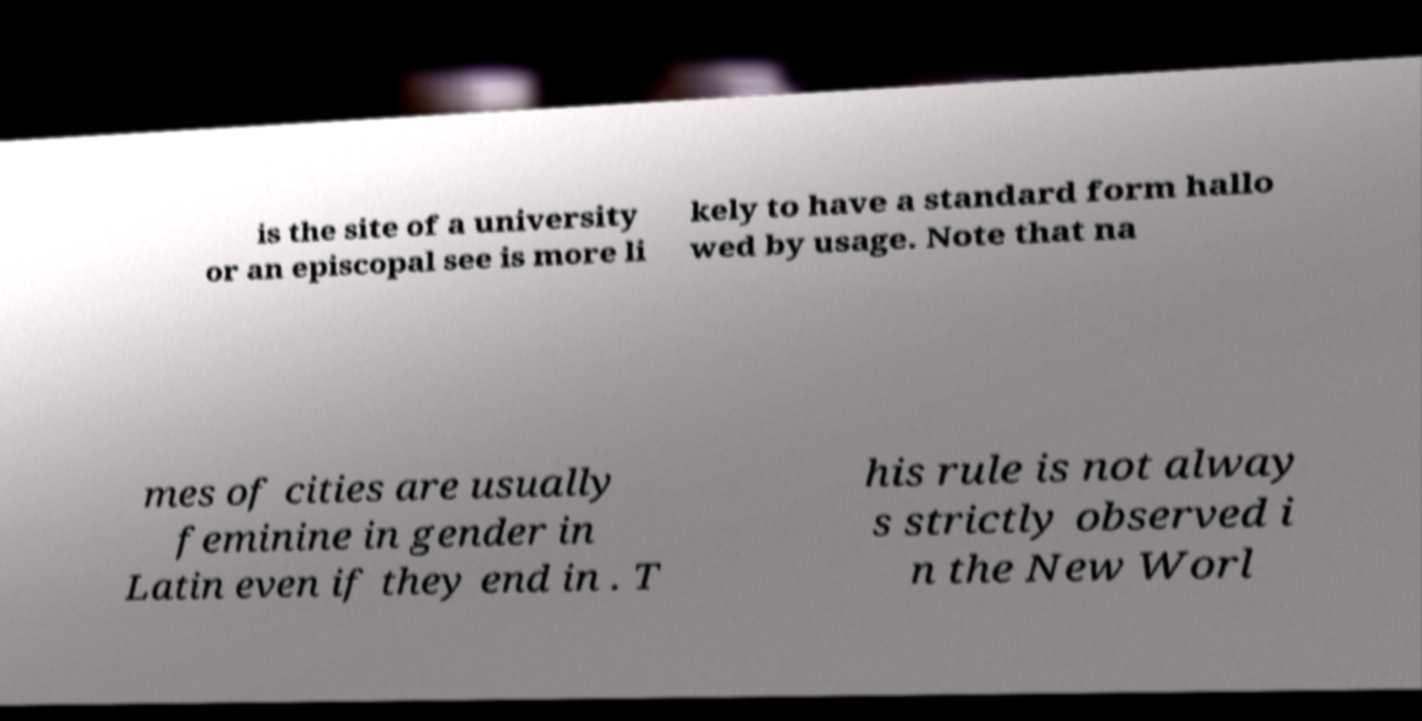Please identify and transcribe the text found in this image. is the site of a university or an episcopal see is more li kely to have a standard form hallo wed by usage. Note that na mes of cities are usually feminine in gender in Latin even if they end in . T his rule is not alway s strictly observed i n the New Worl 